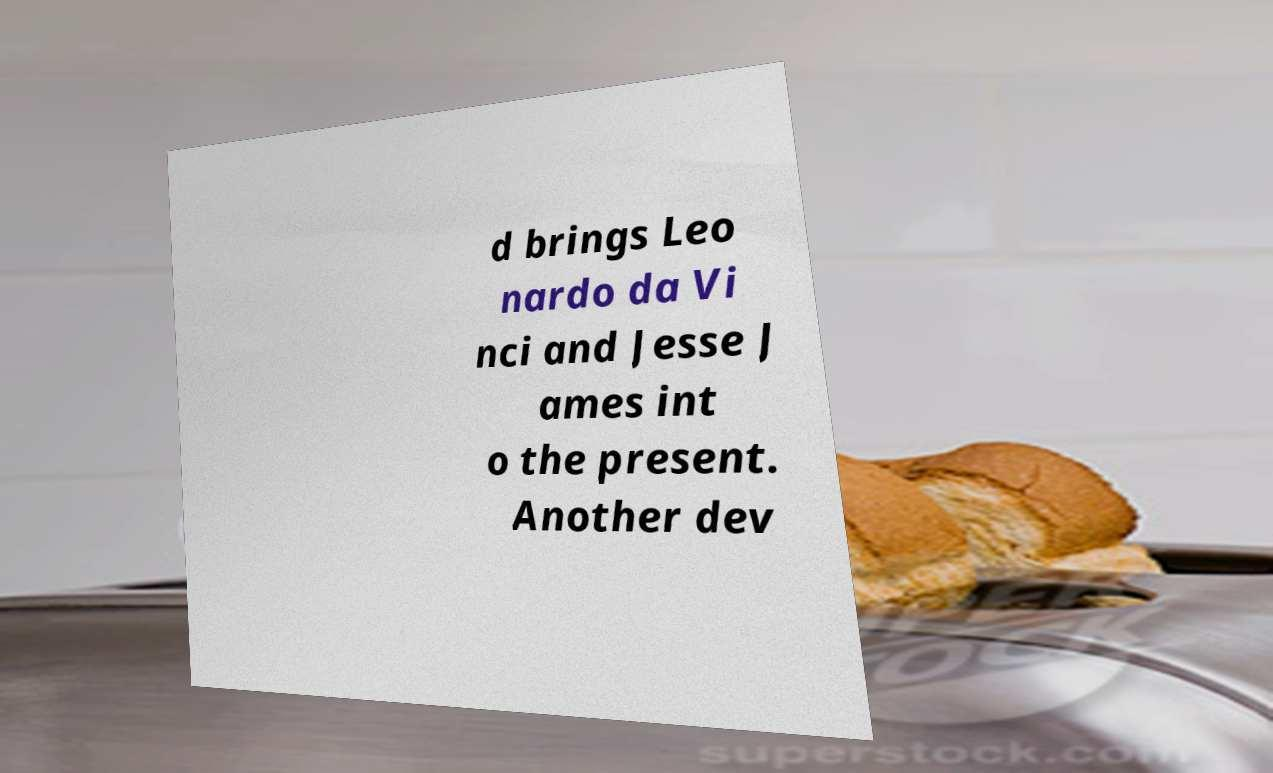For documentation purposes, I need the text within this image transcribed. Could you provide that? d brings Leo nardo da Vi nci and Jesse J ames int o the present. Another dev 